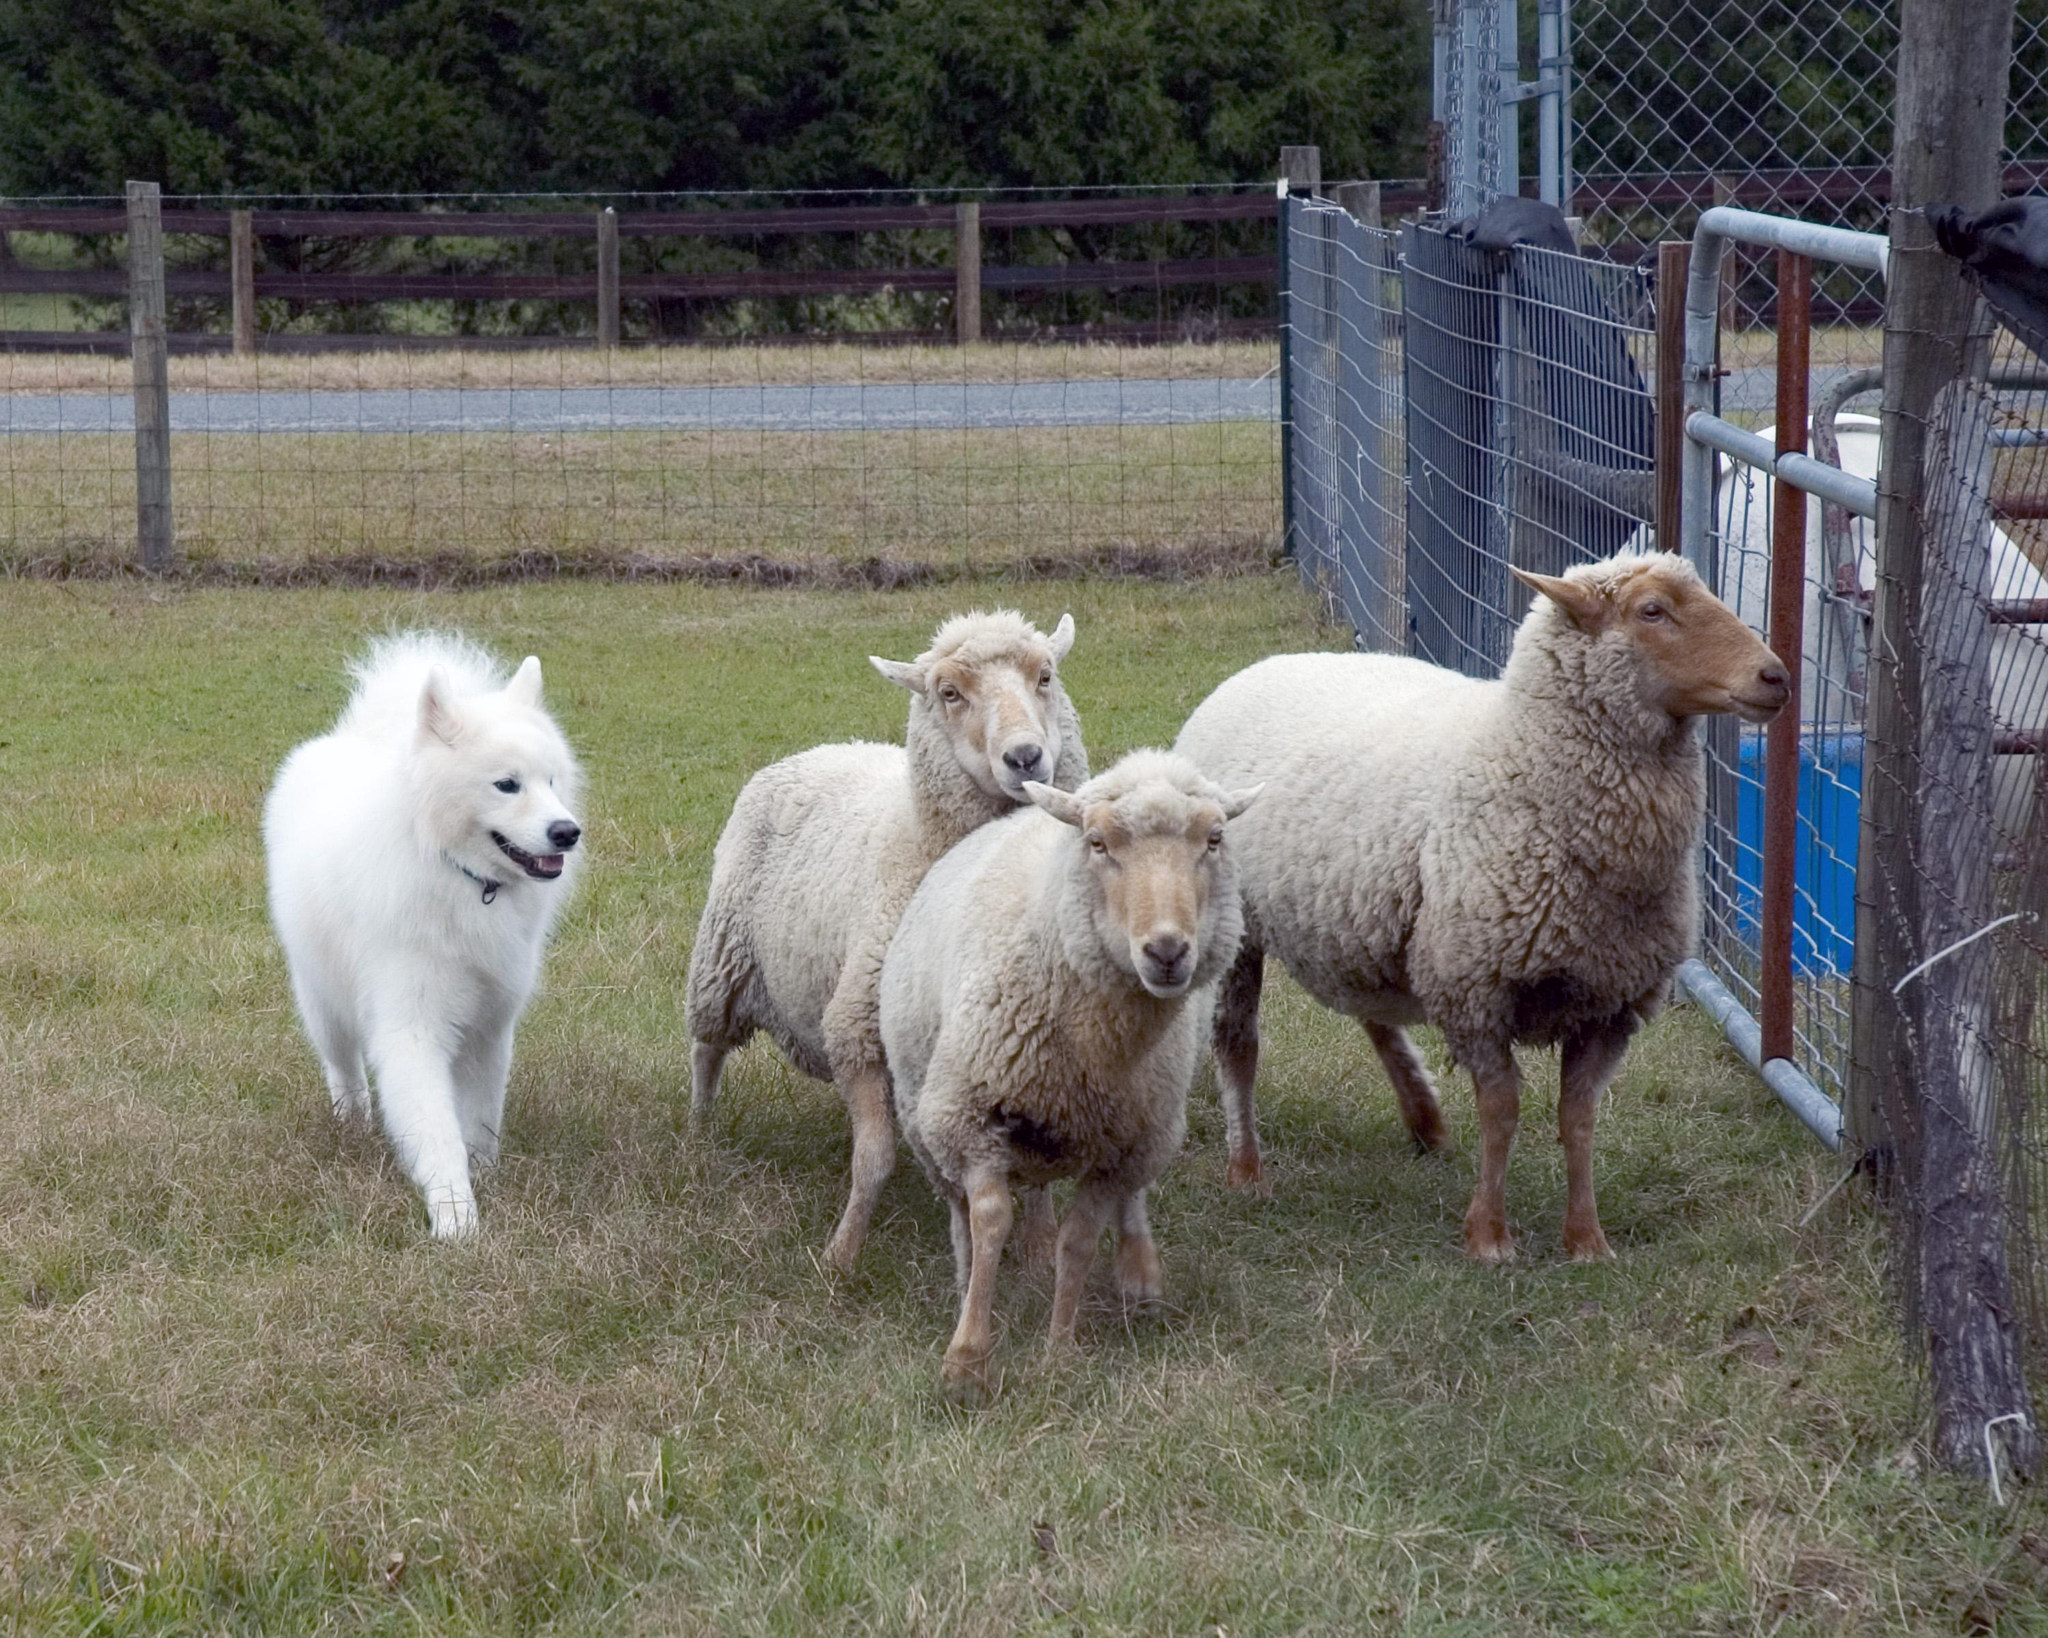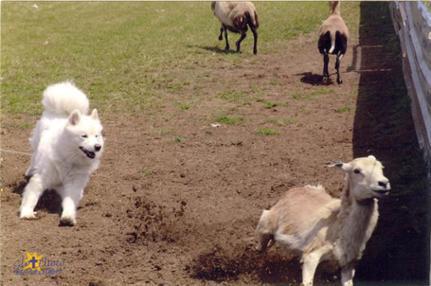The first image is the image on the left, the second image is the image on the right. Examine the images to the left and right. Is the description "A woman holding a stick stands behind multiple woolly sheep and is near a white dog." accurate? Answer yes or no. No. The first image is the image on the left, the second image is the image on the right. Given the left and right images, does the statement "A woman is standing in the field in only one of the images." hold true? Answer yes or no. No. 